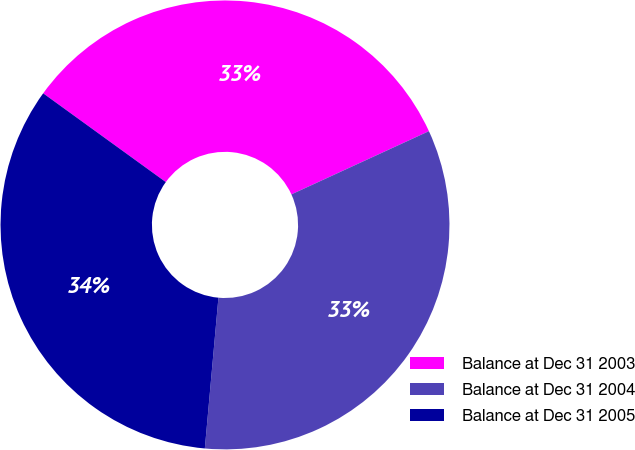Convert chart to OTSL. <chart><loc_0><loc_0><loc_500><loc_500><pie_chart><fcel>Balance at Dec 31 2003<fcel>Balance at Dec 31 2004<fcel>Balance at Dec 31 2005<nl><fcel>33.17%<fcel>33.29%<fcel>33.54%<nl></chart> 